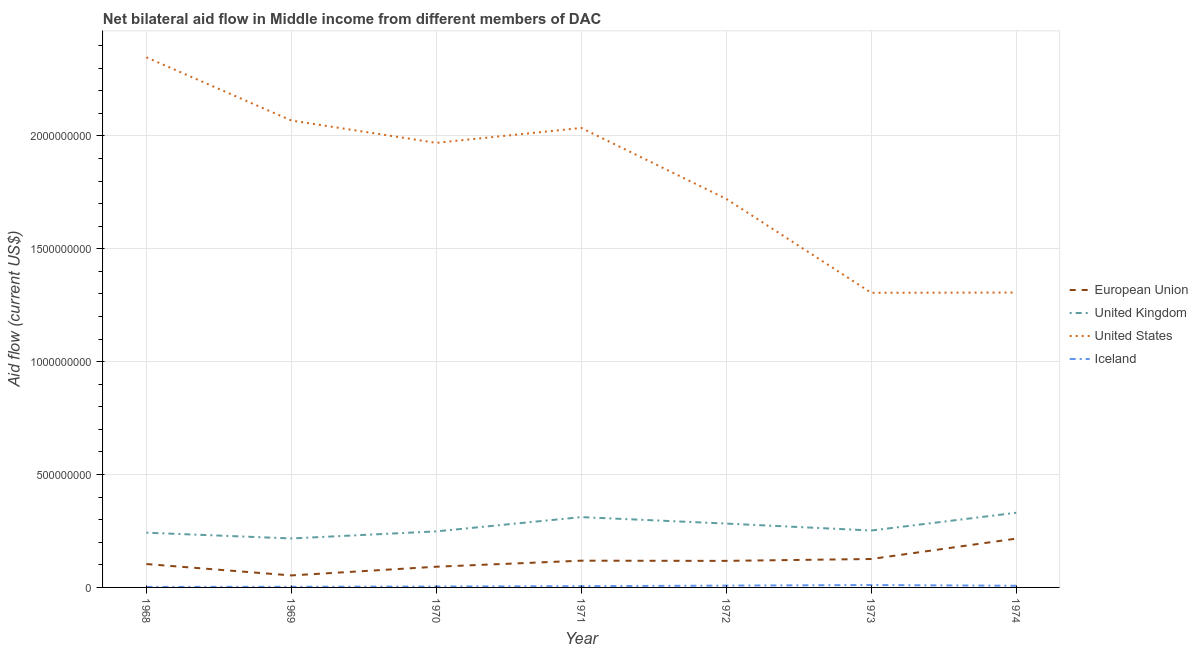Is the number of lines equal to the number of legend labels?
Ensure brevity in your answer.  Yes. What is the amount of aid given by uk in 1974?
Offer a terse response. 3.31e+08. Across all years, what is the maximum amount of aid given by uk?
Offer a very short reply. 3.31e+08. Across all years, what is the minimum amount of aid given by us?
Ensure brevity in your answer.  1.30e+09. In which year was the amount of aid given by uk maximum?
Your response must be concise. 1974. In which year was the amount of aid given by us minimum?
Offer a terse response. 1973. What is the total amount of aid given by uk in the graph?
Your answer should be compact. 1.88e+09. What is the difference between the amount of aid given by us in 1969 and that in 1973?
Your response must be concise. 7.63e+08. What is the difference between the amount of aid given by uk in 1972 and the amount of aid given by us in 1968?
Your response must be concise. -2.07e+09. What is the average amount of aid given by us per year?
Provide a succinct answer. 1.82e+09. In the year 1972, what is the difference between the amount of aid given by eu and amount of aid given by uk?
Your answer should be compact. -1.65e+08. What is the ratio of the amount of aid given by uk in 1970 to that in 1971?
Your response must be concise. 0.8. What is the difference between the highest and the second highest amount of aid given by iceland?
Keep it short and to the point. 2.57e+06. What is the difference between the highest and the lowest amount of aid given by us?
Give a very brief answer. 1.04e+09. Is it the case that in every year, the sum of the amount of aid given by iceland and amount of aid given by uk is greater than the sum of amount of aid given by eu and amount of aid given by us?
Provide a short and direct response. No. How many years are there in the graph?
Give a very brief answer. 7. Does the graph contain any zero values?
Make the answer very short. No. How many legend labels are there?
Your answer should be very brief. 4. How are the legend labels stacked?
Keep it short and to the point. Vertical. What is the title of the graph?
Provide a succinct answer. Net bilateral aid flow in Middle income from different members of DAC. Does "Quality Certification" appear as one of the legend labels in the graph?
Offer a terse response. No. What is the label or title of the X-axis?
Provide a succinct answer. Year. What is the Aid flow (current US$) of European Union in 1968?
Make the answer very short. 1.04e+08. What is the Aid flow (current US$) of United Kingdom in 1968?
Give a very brief answer. 2.42e+08. What is the Aid flow (current US$) of United States in 1968?
Your answer should be compact. 2.35e+09. What is the Aid flow (current US$) in Iceland in 1968?
Provide a short and direct response. 2.25e+06. What is the Aid flow (current US$) in European Union in 1969?
Offer a terse response. 5.32e+07. What is the Aid flow (current US$) in United Kingdom in 1969?
Keep it short and to the point. 2.17e+08. What is the Aid flow (current US$) of United States in 1969?
Provide a succinct answer. 2.07e+09. What is the Aid flow (current US$) of Iceland in 1969?
Offer a very short reply. 2.86e+06. What is the Aid flow (current US$) in European Union in 1970?
Give a very brief answer. 9.17e+07. What is the Aid flow (current US$) in United Kingdom in 1970?
Keep it short and to the point. 2.48e+08. What is the Aid flow (current US$) of United States in 1970?
Offer a very short reply. 1.97e+09. What is the Aid flow (current US$) of Iceland in 1970?
Offer a very short reply. 4.10e+06. What is the Aid flow (current US$) of European Union in 1971?
Your answer should be compact. 1.18e+08. What is the Aid flow (current US$) of United Kingdom in 1971?
Ensure brevity in your answer.  3.11e+08. What is the Aid flow (current US$) of United States in 1971?
Keep it short and to the point. 2.04e+09. What is the Aid flow (current US$) of Iceland in 1971?
Offer a terse response. 5.55e+06. What is the Aid flow (current US$) in European Union in 1972?
Give a very brief answer. 1.18e+08. What is the Aid flow (current US$) of United Kingdom in 1972?
Your answer should be very brief. 2.83e+08. What is the Aid flow (current US$) of United States in 1972?
Offer a very short reply. 1.72e+09. What is the Aid flow (current US$) of Iceland in 1972?
Your response must be concise. 8.06e+06. What is the Aid flow (current US$) in European Union in 1973?
Make the answer very short. 1.26e+08. What is the Aid flow (current US$) in United Kingdom in 1973?
Your response must be concise. 2.52e+08. What is the Aid flow (current US$) in United States in 1973?
Provide a succinct answer. 1.30e+09. What is the Aid flow (current US$) in Iceland in 1973?
Keep it short and to the point. 1.06e+07. What is the Aid flow (current US$) in European Union in 1974?
Give a very brief answer. 2.16e+08. What is the Aid flow (current US$) in United Kingdom in 1974?
Your response must be concise. 3.31e+08. What is the Aid flow (current US$) in United States in 1974?
Give a very brief answer. 1.31e+09. What is the Aid flow (current US$) of Iceland in 1974?
Provide a short and direct response. 7.38e+06. Across all years, what is the maximum Aid flow (current US$) of European Union?
Provide a succinct answer. 2.16e+08. Across all years, what is the maximum Aid flow (current US$) of United Kingdom?
Your answer should be compact. 3.31e+08. Across all years, what is the maximum Aid flow (current US$) of United States?
Offer a terse response. 2.35e+09. Across all years, what is the maximum Aid flow (current US$) of Iceland?
Offer a terse response. 1.06e+07. Across all years, what is the minimum Aid flow (current US$) in European Union?
Offer a terse response. 5.32e+07. Across all years, what is the minimum Aid flow (current US$) in United Kingdom?
Make the answer very short. 2.17e+08. Across all years, what is the minimum Aid flow (current US$) of United States?
Make the answer very short. 1.30e+09. Across all years, what is the minimum Aid flow (current US$) of Iceland?
Keep it short and to the point. 2.25e+06. What is the total Aid flow (current US$) in European Union in the graph?
Provide a short and direct response. 8.27e+08. What is the total Aid flow (current US$) of United Kingdom in the graph?
Offer a terse response. 1.88e+09. What is the total Aid flow (current US$) of United States in the graph?
Make the answer very short. 1.28e+1. What is the total Aid flow (current US$) in Iceland in the graph?
Your answer should be very brief. 4.08e+07. What is the difference between the Aid flow (current US$) in European Union in 1968 and that in 1969?
Your answer should be compact. 5.04e+07. What is the difference between the Aid flow (current US$) in United Kingdom in 1968 and that in 1969?
Provide a succinct answer. 2.55e+07. What is the difference between the Aid flow (current US$) in United States in 1968 and that in 1969?
Your answer should be very brief. 2.80e+08. What is the difference between the Aid flow (current US$) of Iceland in 1968 and that in 1969?
Provide a succinct answer. -6.10e+05. What is the difference between the Aid flow (current US$) in European Union in 1968 and that in 1970?
Ensure brevity in your answer.  1.19e+07. What is the difference between the Aid flow (current US$) in United Kingdom in 1968 and that in 1970?
Your answer should be very brief. -5.81e+06. What is the difference between the Aid flow (current US$) in United States in 1968 and that in 1970?
Ensure brevity in your answer.  3.79e+08. What is the difference between the Aid flow (current US$) in Iceland in 1968 and that in 1970?
Offer a very short reply. -1.85e+06. What is the difference between the Aid flow (current US$) in European Union in 1968 and that in 1971?
Your response must be concise. -1.48e+07. What is the difference between the Aid flow (current US$) in United Kingdom in 1968 and that in 1971?
Ensure brevity in your answer.  -6.90e+07. What is the difference between the Aid flow (current US$) of United States in 1968 and that in 1971?
Offer a terse response. 3.13e+08. What is the difference between the Aid flow (current US$) of Iceland in 1968 and that in 1971?
Your answer should be very brief. -3.30e+06. What is the difference between the Aid flow (current US$) in European Union in 1968 and that in 1972?
Provide a succinct answer. -1.40e+07. What is the difference between the Aid flow (current US$) in United Kingdom in 1968 and that in 1972?
Offer a very short reply. -4.04e+07. What is the difference between the Aid flow (current US$) of United States in 1968 and that in 1972?
Give a very brief answer. 6.27e+08. What is the difference between the Aid flow (current US$) in Iceland in 1968 and that in 1972?
Make the answer very short. -5.81e+06. What is the difference between the Aid flow (current US$) of European Union in 1968 and that in 1973?
Offer a terse response. -2.23e+07. What is the difference between the Aid flow (current US$) of United Kingdom in 1968 and that in 1973?
Make the answer very short. -9.66e+06. What is the difference between the Aid flow (current US$) in United States in 1968 and that in 1973?
Provide a short and direct response. 1.04e+09. What is the difference between the Aid flow (current US$) in Iceland in 1968 and that in 1973?
Make the answer very short. -8.38e+06. What is the difference between the Aid flow (current US$) of European Union in 1968 and that in 1974?
Your response must be concise. -1.13e+08. What is the difference between the Aid flow (current US$) of United Kingdom in 1968 and that in 1974?
Keep it short and to the point. -8.82e+07. What is the difference between the Aid flow (current US$) in United States in 1968 and that in 1974?
Keep it short and to the point. 1.04e+09. What is the difference between the Aid flow (current US$) of Iceland in 1968 and that in 1974?
Offer a very short reply. -5.13e+06. What is the difference between the Aid flow (current US$) of European Union in 1969 and that in 1970?
Offer a terse response. -3.86e+07. What is the difference between the Aid flow (current US$) of United Kingdom in 1969 and that in 1970?
Your answer should be very brief. -3.13e+07. What is the difference between the Aid flow (current US$) of United States in 1969 and that in 1970?
Provide a succinct answer. 9.90e+07. What is the difference between the Aid flow (current US$) of Iceland in 1969 and that in 1970?
Ensure brevity in your answer.  -1.24e+06. What is the difference between the Aid flow (current US$) in European Union in 1969 and that in 1971?
Give a very brief answer. -6.53e+07. What is the difference between the Aid flow (current US$) of United Kingdom in 1969 and that in 1971?
Provide a succinct answer. -9.45e+07. What is the difference between the Aid flow (current US$) of United States in 1969 and that in 1971?
Ensure brevity in your answer.  3.30e+07. What is the difference between the Aid flow (current US$) in Iceland in 1969 and that in 1971?
Your answer should be very brief. -2.69e+06. What is the difference between the Aid flow (current US$) in European Union in 1969 and that in 1972?
Your answer should be compact. -6.44e+07. What is the difference between the Aid flow (current US$) of United Kingdom in 1969 and that in 1972?
Ensure brevity in your answer.  -6.59e+07. What is the difference between the Aid flow (current US$) in United States in 1969 and that in 1972?
Provide a succinct answer. 3.47e+08. What is the difference between the Aid flow (current US$) in Iceland in 1969 and that in 1972?
Your answer should be compact. -5.20e+06. What is the difference between the Aid flow (current US$) of European Union in 1969 and that in 1973?
Provide a short and direct response. -7.28e+07. What is the difference between the Aid flow (current US$) in United Kingdom in 1969 and that in 1973?
Keep it short and to the point. -3.52e+07. What is the difference between the Aid flow (current US$) in United States in 1969 and that in 1973?
Keep it short and to the point. 7.63e+08. What is the difference between the Aid flow (current US$) in Iceland in 1969 and that in 1973?
Provide a succinct answer. -7.77e+06. What is the difference between the Aid flow (current US$) in European Union in 1969 and that in 1974?
Keep it short and to the point. -1.63e+08. What is the difference between the Aid flow (current US$) in United Kingdom in 1969 and that in 1974?
Ensure brevity in your answer.  -1.14e+08. What is the difference between the Aid flow (current US$) in United States in 1969 and that in 1974?
Provide a succinct answer. 7.62e+08. What is the difference between the Aid flow (current US$) in Iceland in 1969 and that in 1974?
Keep it short and to the point. -4.52e+06. What is the difference between the Aid flow (current US$) in European Union in 1970 and that in 1971?
Your answer should be compact. -2.67e+07. What is the difference between the Aid flow (current US$) of United Kingdom in 1970 and that in 1971?
Offer a terse response. -6.32e+07. What is the difference between the Aid flow (current US$) in United States in 1970 and that in 1971?
Ensure brevity in your answer.  -6.60e+07. What is the difference between the Aid flow (current US$) in Iceland in 1970 and that in 1971?
Make the answer very short. -1.45e+06. What is the difference between the Aid flow (current US$) of European Union in 1970 and that in 1972?
Make the answer very short. -2.59e+07. What is the difference between the Aid flow (current US$) of United Kingdom in 1970 and that in 1972?
Provide a short and direct response. -3.46e+07. What is the difference between the Aid flow (current US$) of United States in 1970 and that in 1972?
Your answer should be compact. 2.48e+08. What is the difference between the Aid flow (current US$) in Iceland in 1970 and that in 1972?
Your response must be concise. -3.96e+06. What is the difference between the Aid flow (current US$) of European Union in 1970 and that in 1973?
Keep it short and to the point. -3.42e+07. What is the difference between the Aid flow (current US$) of United Kingdom in 1970 and that in 1973?
Give a very brief answer. -3.85e+06. What is the difference between the Aid flow (current US$) in United States in 1970 and that in 1973?
Ensure brevity in your answer.  6.64e+08. What is the difference between the Aid flow (current US$) in Iceland in 1970 and that in 1973?
Make the answer very short. -6.53e+06. What is the difference between the Aid flow (current US$) in European Union in 1970 and that in 1974?
Offer a very short reply. -1.24e+08. What is the difference between the Aid flow (current US$) of United Kingdom in 1970 and that in 1974?
Give a very brief answer. -8.24e+07. What is the difference between the Aid flow (current US$) of United States in 1970 and that in 1974?
Keep it short and to the point. 6.63e+08. What is the difference between the Aid flow (current US$) in Iceland in 1970 and that in 1974?
Give a very brief answer. -3.28e+06. What is the difference between the Aid flow (current US$) of European Union in 1971 and that in 1972?
Offer a terse response. 8.10e+05. What is the difference between the Aid flow (current US$) of United Kingdom in 1971 and that in 1972?
Keep it short and to the point. 2.86e+07. What is the difference between the Aid flow (current US$) of United States in 1971 and that in 1972?
Offer a terse response. 3.14e+08. What is the difference between the Aid flow (current US$) of Iceland in 1971 and that in 1972?
Offer a very short reply. -2.51e+06. What is the difference between the Aid flow (current US$) of European Union in 1971 and that in 1973?
Make the answer very short. -7.50e+06. What is the difference between the Aid flow (current US$) of United Kingdom in 1971 and that in 1973?
Give a very brief answer. 5.93e+07. What is the difference between the Aid flow (current US$) of United States in 1971 and that in 1973?
Offer a terse response. 7.30e+08. What is the difference between the Aid flow (current US$) in Iceland in 1971 and that in 1973?
Your response must be concise. -5.08e+06. What is the difference between the Aid flow (current US$) in European Union in 1971 and that in 1974?
Your response must be concise. -9.78e+07. What is the difference between the Aid flow (current US$) in United Kingdom in 1971 and that in 1974?
Provide a short and direct response. -1.92e+07. What is the difference between the Aid flow (current US$) of United States in 1971 and that in 1974?
Make the answer very short. 7.29e+08. What is the difference between the Aid flow (current US$) of Iceland in 1971 and that in 1974?
Give a very brief answer. -1.83e+06. What is the difference between the Aid flow (current US$) in European Union in 1972 and that in 1973?
Your answer should be very brief. -8.31e+06. What is the difference between the Aid flow (current US$) of United Kingdom in 1972 and that in 1973?
Offer a terse response. 3.08e+07. What is the difference between the Aid flow (current US$) of United States in 1972 and that in 1973?
Give a very brief answer. 4.16e+08. What is the difference between the Aid flow (current US$) of Iceland in 1972 and that in 1973?
Give a very brief answer. -2.57e+06. What is the difference between the Aid flow (current US$) in European Union in 1972 and that in 1974?
Offer a terse response. -9.86e+07. What is the difference between the Aid flow (current US$) in United Kingdom in 1972 and that in 1974?
Provide a succinct answer. -4.78e+07. What is the difference between the Aid flow (current US$) in United States in 1972 and that in 1974?
Offer a very short reply. 4.15e+08. What is the difference between the Aid flow (current US$) of Iceland in 1972 and that in 1974?
Provide a succinct answer. 6.80e+05. What is the difference between the Aid flow (current US$) in European Union in 1973 and that in 1974?
Provide a succinct answer. -9.03e+07. What is the difference between the Aid flow (current US$) in United Kingdom in 1973 and that in 1974?
Your answer should be very brief. -7.86e+07. What is the difference between the Aid flow (current US$) in United States in 1973 and that in 1974?
Offer a very short reply. -1.00e+06. What is the difference between the Aid flow (current US$) in Iceland in 1973 and that in 1974?
Your answer should be compact. 3.25e+06. What is the difference between the Aid flow (current US$) in European Union in 1968 and the Aid flow (current US$) in United Kingdom in 1969?
Provide a succinct answer. -1.13e+08. What is the difference between the Aid flow (current US$) in European Union in 1968 and the Aid flow (current US$) in United States in 1969?
Offer a very short reply. -1.96e+09. What is the difference between the Aid flow (current US$) of European Union in 1968 and the Aid flow (current US$) of Iceland in 1969?
Offer a very short reply. 1.01e+08. What is the difference between the Aid flow (current US$) in United Kingdom in 1968 and the Aid flow (current US$) in United States in 1969?
Your answer should be very brief. -1.83e+09. What is the difference between the Aid flow (current US$) of United Kingdom in 1968 and the Aid flow (current US$) of Iceland in 1969?
Ensure brevity in your answer.  2.40e+08. What is the difference between the Aid flow (current US$) in United States in 1968 and the Aid flow (current US$) in Iceland in 1969?
Your answer should be very brief. 2.35e+09. What is the difference between the Aid flow (current US$) of European Union in 1968 and the Aid flow (current US$) of United Kingdom in 1970?
Offer a terse response. -1.45e+08. What is the difference between the Aid flow (current US$) in European Union in 1968 and the Aid flow (current US$) in United States in 1970?
Keep it short and to the point. -1.87e+09. What is the difference between the Aid flow (current US$) of European Union in 1968 and the Aid flow (current US$) of Iceland in 1970?
Ensure brevity in your answer.  9.95e+07. What is the difference between the Aid flow (current US$) of United Kingdom in 1968 and the Aid flow (current US$) of United States in 1970?
Provide a short and direct response. -1.73e+09. What is the difference between the Aid flow (current US$) in United Kingdom in 1968 and the Aid flow (current US$) in Iceland in 1970?
Offer a very short reply. 2.38e+08. What is the difference between the Aid flow (current US$) in United States in 1968 and the Aid flow (current US$) in Iceland in 1970?
Provide a succinct answer. 2.34e+09. What is the difference between the Aid flow (current US$) of European Union in 1968 and the Aid flow (current US$) of United Kingdom in 1971?
Give a very brief answer. -2.08e+08. What is the difference between the Aid flow (current US$) of European Union in 1968 and the Aid flow (current US$) of United States in 1971?
Make the answer very short. -1.93e+09. What is the difference between the Aid flow (current US$) of European Union in 1968 and the Aid flow (current US$) of Iceland in 1971?
Make the answer very short. 9.80e+07. What is the difference between the Aid flow (current US$) in United Kingdom in 1968 and the Aid flow (current US$) in United States in 1971?
Provide a succinct answer. -1.79e+09. What is the difference between the Aid flow (current US$) of United Kingdom in 1968 and the Aid flow (current US$) of Iceland in 1971?
Offer a terse response. 2.37e+08. What is the difference between the Aid flow (current US$) of United States in 1968 and the Aid flow (current US$) of Iceland in 1971?
Offer a very short reply. 2.34e+09. What is the difference between the Aid flow (current US$) in European Union in 1968 and the Aid flow (current US$) in United Kingdom in 1972?
Your answer should be compact. -1.79e+08. What is the difference between the Aid flow (current US$) in European Union in 1968 and the Aid flow (current US$) in United States in 1972?
Give a very brief answer. -1.62e+09. What is the difference between the Aid flow (current US$) of European Union in 1968 and the Aid flow (current US$) of Iceland in 1972?
Offer a very short reply. 9.55e+07. What is the difference between the Aid flow (current US$) in United Kingdom in 1968 and the Aid flow (current US$) in United States in 1972?
Provide a succinct answer. -1.48e+09. What is the difference between the Aid flow (current US$) of United Kingdom in 1968 and the Aid flow (current US$) of Iceland in 1972?
Ensure brevity in your answer.  2.34e+08. What is the difference between the Aid flow (current US$) in United States in 1968 and the Aid flow (current US$) in Iceland in 1972?
Your response must be concise. 2.34e+09. What is the difference between the Aid flow (current US$) of European Union in 1968 and the Aid flow (current US$) of United Kingdom in 1973?
Your answer should be very brief. -1.48e+08. What is the difference between the Aid flow (current US$) of European Union in 1968 and the Aid flow (current US$) of United States in 1973?
Give a very brief answer. -1.20e+09. What is the difference between the Aid flow (current US$) of European Union in 1968 and the Aid flow (current US$) of Iceland in 1973?
Offer a very short reply. 9.30e+07. What is the difference between the Aid flow (current US$) in United Kingdom in 1968 and the Aid flow (current US$) in United States in 1973?
Your answer should be compact. -1.06e+09. What is the difference between the Aid flow (current US$) of United Kingdom in 1968 and the Aid flow (current US$) of Iceland in 1973?
Your response must be concise. 2.32e+08. What is the difference between the Aid flow (current US$) in United States in 1968 and the Aid flow (current US$) in Iceland in 1973?
Provide a short and direct response. 2.34e+09. What is the difference between the Aid flow (current US$) in European Union in 1968 and the Aid flow (current US$) in United Kingdom in 1974?
Make the answer very short. -2.27e+08. What is the difference between the Aid flow (current US$) in European Union in 1968 and the Aid flow (current US$) in United States in 1974?
Your answer should be very brief. -1.20e+09. What is the difference between the Aid flow (current US$) in European Union in 1968 and the Aid flow (current US$) in Iceland in 1974?
Offer a terse response. 9.62e+07. What is the difference between the Aid flow (current US$) in United Kingdom in 1968 and the Aid flow (current US$) in United States in 1974?
Ensure brevity in your answer.  -1.06e+09. What is the difference between the Aid flow (current US$) in United Kingdom in 1968 and the Aid flow (current US$) in Iceland in 1974?
Offer a very short reply. 2.35e+08. What is the difference between the Aid flow (current US$) of United States in 1968 and the Aid flow (current US$) of Iceland in 1974?
Provide a succinct answer. 2.34e+09. What is the difference between the Aid flow (current US$) of European Union in 1969 and the Aid flow (current US$) of United Kingdom in 1970?
Your response must be concise. -1.95e+08. What is the difference between the Aid flow (current US$) in European Union in 1969 and the Aid flow (current US$) in United States in 1970?
Offer a terse response. -1.92e+09. What is the difference between the Aid flow (current US$) in European Union in 1969 and the Aid flow (current US$) in Iceland in 1970?
Provide a succinct answer. 4.90e+07. What is the difference between the Aid flow (current US$) in United Kingdom in 1969 and the Aid flow (current US$) in United States in 1970?
Provide a succinct answer. -1.75e+09. What is the difference between the Aid flow (current US$) of United Kingdom in 1969 and the Aid flow (current US$) of Iceland in 1970?
Your answer should be very brief. 2.13e+08. What is the difference between the Aid flow (current US$) of United States in 1969 and the Aid flow (current US$) of Iceland in 1970?
Provide a succinct answer. 2.06e+09. What is the difference between the Aid flow (current US$) of European Union in 1969 and the Aid flow (current US$) of United Kingdom in 1971?
Make the answer very short. -2.58e+08. What is the difference between the Aid flow (current US$) in European Union in 1969 and the Aid flow (current US$) in United States in 1971?
Your answer should be very brief. -1.98e+09. What is the difference between the Aid flow (current US$) of European Union in 1969 and the Aid flow (current US$) of Iceland in 1971?
Give a very brief answer. 4.76e+07. What is the difference between the Aid flow (current US$) in United Kingdom in 1969 and the Aid flow (current US$) in United States in 1971?
Provide a succinct answer. -1.82e+09. What is the difference between the Aid flow (current US$) of United Kingdom in 1969 and the Aid flow (current US$) of Iceland in 1971?
Make the answer very short. 2.11e+08. What is the difference between the Aid flow (current US$) in United States in 1969 and the Aid flow (current US$) in Iceland in 1971?
Ensure brevity in your answer.  2.06e+09. What is the difference between the Aid flow (current US$) of European Union in 1969 and the Aid flow (current US$) of United Kingdom in 1972?
Keep it short and to the point. -2.30e+08. What is the difference between the Aid flow (current US$) of European Union in 1969 and the Aid flow (current US$) of United States in 1972?
Ensure brevity in your answer.  -1.67e+09. What is the difference between the Aid flow (current US$) in European Union in 1969 and the Aid flow (current US$) in Iceland in 1972?
Keep it short and to the point. 4.51e+07. What is the difference between the Aid flow (current US$) in United Kingdom in 1969 and the Aid flow (current US$) in United States in 1972?
Your response must be concise. -1.50e+09. What is the difference between the Aid flow (current US$) in United Kingdom in 1969 and the Aid flow (current US$) in Iceland in 1972?
Provide a short and direct response. 2.09e+08. What is the difference between the Aid flow (current US$) in United States in 1969 and the Aid flow (current US$) in Iceland in 1972?
Offer a very short reply. 2.06e+09. What is the difference between the Aid flow (current US$) of European Union in 1969 and the Aid flow (current US$) of United Kingdom in 1973?
Ensure brevity in your answer.  -1.99e+08. What is the difference between the Aid flow (current US$) in European Union in 1969 and the Aid flow (current US$) in United States in 1973?
Make the answer very short. -1.25e+09. What is the difference between the Aid flow (current US$) in European Union in 1969 and the Aid flow (current US$) in Iceland in 1973?
Provide a succinct answer. 4.25e+07. What is the difference between the Aid flow (current US$) in United Kingdom in 1969 and the Aid flow (current US$) in United States in 1973?
Offer a terse response. -1.09e+09. What is the difference between the Aid flow (current US$) of United Kingdom in 1969 and the Aid flow (current US$) of Iceland in 1973?
Give a very brief answer. 2.06e+08. What is the difference between the Aid flow (current US$) of United States in 1969 and the Aid flow (current US$) of Iceland in 1973?
Offer a terse response. 2.06e+09. What is the difference between the Aid flow (current US$) in European Union in 1969 and the Aid flow (current US$) in United Kingdom in 1974?
Your answer should be very brief. -2.77e+08. What is the difference between the Aid flow (current US$) in European Union in 1969 and the Aid flow (current US$) in United States in 1974?
Offer a terse response. -1.25e+09. What is the difference between the Aid flow (current US$) of European Union in 1969 and the Aid flow (current US$) of Iceland in 1974?
Your answer should be compact. 4.58e+07. What is the difference between the Aid flow (current US$) in United Kingdom in 1969 and the Aid flow (current US$) in United States in 1974?
Provide a succinct answer. -1.09e+09. What is the difference between the Aid flow (current US$) of United Kingdom in 1969 and the Aid flow (current US$) of Iceland in 1974?
Provide a succinct answer. 2.10e+08. What is the difference between the Aid flow (current US$) in United States in 1969 and the Aid flow (current US$) in Iceland in 1974?
Ensure brevity in your answer.  2.06e+09. What is the difference between the Aid flow (current US$) of European Union in 1970 and the Aid flow (current US$) of United Kingdom in 1971?
Your answer should be very brief. -2.20e+08. What is the difference between the Aid flow (current US$) in European Union in 1970 and the Aid flow (current US$) in United States in 1971?
Provide a succinct answer. -1.94e+09. What is the difference between the Aid flow (current US$) of European Union in 1970 and the Aid flow (current US$) of Iceland in 1971?
Offer a terse response. 8.62e+07. What is the difference between the Aid flow (current US$) in United Kingdom in 1970 and the Aid flow (current US$) in United States in 1971?
Offer a terse response. -1.79e+09. What is the difference between the Aid flow (current US$) in United Kingdom in 1970 and the Aid flow (current US$) in Iceland in 1971?
Keep it short and to the point. 2.43e+08. What is the difference between the Aid flow (current US$) in United States in 1970 and the Aid flow (current US$) in Iceland in 1971?
Provide a succinct answer. 1.96e+09. What is the difference between the Aid flow (current US$) in European Union in 1970 and the Aid flow (current US$) in United Kingdom in 1972?
Offer a very short reply. -1.91e+08. What is the difference between the Aid flow (current US$) of European Union in 1970 and the Aid flow (current US$) of United States in 1972?
Your response must be concise. -1.63e+09. What is the difference between the Aid flow (current US$) of European Union in 1970 and the Aid flow (current US$) of Iceland in 1972?
Provide a succinct answer. 8.37e+07. What is the difference between the Aid flow (current US$) in United Kingdom in 1970 and the Aid flow (current US$) in United States in 1972?
Provide a succinct answer. -1.47e+09. What is the difference between the Aid flow (current US$) in United Kingdom in 1970 and the Aid flow (current US$) in Iceland in 1972?
Your answer should be compact. 2.40e+08. What is the difference between the Aid flow (current US$) of United States in 1970 and the Aid flow (current US$) of Iceland in 1972?
Provide a succinct answer. 1.96e+09. What is the difference between the Aid flow (current US$) of European Union in 1970 and the Aid flow (current US$) of United Kingdom in 1973?
Your response must be concise. -1.60e+08. What is the difference between the Aid flow (current US$) of European Union in 1970 and the Aid flow (current US$) of United States in 1973?
Offer a very short reply. -1.21e+09. What is the difference between the Aid flow (current US$) in European Union in 1970 and the Aid flow (current US$) in Iceland in 1973?
Make the answer very short. 8.11e+07. What is the difference between the Aid flow (current US$) in United Kingdom in 1970 and the Aid flow (current US$) in United States in 1973?
Offer a terse response. -1.06e+09. What is the difference between the Aid flow (current US$) of United Kingdom in 1970 and the Aid flow (current US$) of Iceland in 1973?
Your answer should be compact. 2.38e+08. What is the difference between the Aid flow (current US$) in United States in 1970 and the Aid flow (current US$) in Iceland in 1973?
Provide a succinct answer. 1.96e+09. What is the difference between the Aid flow (current US$) of European Union in 1970 and the Aid flow (current US$) of United Kingdom in 1974?
Give a very brief answer. -2.39e+08. What is the difference between the Aid flow (current US$) of European Union in 1970 and the Aid flow (current US$) of United States in 1974?
Your answer should be compact. -1.21e+09. What is the difference between the Aid flow (current US$) in European Union in 1970 and the Aid flow (current US$) in Iceland in 1974?
Keep it short and to the point. 8.43e+07. What is the difference between the Aid flow (current US$) in United Kingdom in 1970 and the Aid flow (current US$) in United States in 1974?
Your answer should be compact. -1.06e+09. What is the difference between the Aid flow (current US$) of United Kingdom in 1970 and the Aid flow (current US$) of Iceland in 1974?
Your answer should be very brief. 2.41e+08. What is the difference between the Aid flow (current US$) in United States in 1970 and the Aid flow (current US$) in Iceland in 1974?
Your answer should be very brief. 1.96e+09. What is the difference between the Aid flow (current US$) in European Union in 1971 and the Aid flow (current US$) in United Kingdom in 1972?
Your answer should be very brief. -1.64e+08. What is the difference between the Aid flow (current US$) of European Union in 1971 and the Aid flow (current US$) of United States in 1972?
Give a very brief answer. -1.60e+09. What is the difference between the Aid flow (current US$) in European Union in 1971 and the Aid flow (current US$) in Iceland in 1972?
Offer a terse response. 1.10e+08. What is the difference between the Aid flow (current US$) of United Kingdom in 1971 and the Aid flow (current US$) of United States in 1972?
Your answer should be very brief. -1.41e+09. What is the difference between the Aid flow (current US$) in United Kingdom in 1971 and the Aid flow (current US$) in Iceland in 1972?
Give a very brief answer. 3.03e+08. What is the difference between the Aid flow (current US$) of United States in 1971 and the Aid flow (current US$) of Iceland in 1972?
Your answer should be compact. 2.03e+09. What is the difference between the Aid flow (current US$) of European Union in 1971 and the Aid flow (current US$) of United Kingdom in 1973?
Give a very brief answer. -1.34e+08. What is the difference between the Aid flow (current US$) in European Union in 1971 and the Aid flow (current US$) in United States in 1973?
Your response must be concise. -1.19e+09. What is the difference between the Aid flow (current US$) of European Union in 1971 and the Aid flow (current US$) of Iceland in 1973?
Keep it short and to the point. 1.08e+08. What is the difference between the Aid flow (current US$) in United Kingdom in 1971 and the Aid flow (current US$) in United States in 1973?
Ensure brevity in your answer.  -9.94e+08. What is the difference between the Aid flow (current US$) of United Kingdom in 1971 and the Aid flow (current US$) of Iceland in 1973?
Give a very brief answer. 3.01e+08. What is the difference between the Aid flow (current US$) in United States in 1971 and the Aid flow (current US$) in Iceland in 1973?
Give a very brief answer. 2.02e+09. What is the difference between the Aid flow (current US$) in European Union in 1971 and the Aid flow (current US$) in United Kingdom in 1974?
Provide a succinct answer. -2.12e+08. What is the difference between the Aid flow (current US$) of European Union in 1971 and the Aid flow (current US$) of United States in 1974?
Offer a terse response. -1.19e+09. What is the difference between the Aid flow (current US$) in European Union in 1971 and the Aid flow (current US$) in Iceland in 1974?
Keep it short and to the point. 1.11e+08. What is the difference between the Aid flow (current US$) of United Kingdom in 1971 and the Aid flow (current US$) of United States in 1974?
Offer a terse response. -9.95e+08. What is the difference between the Aid flow (current US$) of United Kingdom in 1971 and the Aid flow (current US$) of Iceland in 1974?
Make the answer very short. 3.04e+08. What is the difference between the Aid flow (current US$) of United States in 1971 and the Aid flow (current US$) of Iceland in 1974?
Your answer should be very brief. 2.03e+09. What is the difference between the Aid flow (current US$) in European Union in 1972 and the Aid flow (current US$) in United Kingdom in 1973?
Provide a short and direct response. -1.34e+08. What is the difference between the Aid flow (current US$) in European Union in 1972 and the Aid flow (current US$) in United States in 1973?
Make the answer very short. -1.19e+09. What is the difference between the Aid flow (current US$) of European Union in 1972 and the Aid flow (current US$) of Iceland in 1973?
Offer a terse response. 1.07e+08. What is the difference between the Aid flow (current US$) in United Kingdom in 1972 and the Aid flow (current US$) in United States in 1973?
Provide a short and direct response. -1.02e+09. What is the difference between the Aid flow (current US$) in United Kingdom in 1972 and the Aid flow (current US$) in Iceland in 1973?
Offer a terse response. 2.72e+08. What is the difference between the Aid flow (current US$) in United States in 1972 and the Aid flow (current US$) in Iceland in 1973?
Provide a short and direct response. 1.71e+09. What is the difference between the Aid flow (current US$) in European Union in 1972 and the Aid flow (current US$) in United Kingdom in 1974?
Ensure brevity in your answer.  -2.13e+08. What is the difference between the Aid flow (current US$) of European Union in 1972 and the Aid flow (current US$) of United States in 1974?
Make the answer very short. -1.19e+09. What is the difference between the Aid flow (current US$) in European Union in 1972 and the Aid flow (current US$) in Iceland in 1974?
Your response must be concise. 1.10e+08. What is the difference between the Aid flow (current US$) of United Kingdom in 1972 and the Aid flow (current US$) of United States in 1974?
Keep it short and to the point. -1.02e+09. What is the difference between the Aid flow (current US$) of United Kingdom in 1972 and the Aid flow (current US$) of Iceland in 1974?
Keep it short and to the point. 2.75e+08. What is the difference between the Aid flow (current US$) in United States in 1972 and the Aid flow (current US$) in Iceland in 1974?
Your response must be concise. 1.71e+09. What is the difference between the Aid flow (current US$) in European Union in 1973 and the Aid flow (current US$) in United Kingdom in 1974?
Your answer should be very brief. -2.05e+08. What is the difference between the Aid flow (current US$) in European Union in 1973 and the Aid flow (current US$) in United States in 1974?
Offer a very short reply. -1.18e+09. What is the difference between the Aid flow (current US$) in European Union in 1973 and the Aid flow (current US$) in Iceland in 1974?
Offer a very short reply. 1.19e+08. What is the difference between the Aid flow (current US$) of United Kingdom in 1973 and the Aid flow (current US$) of United States in 1974?
Provide a succinct answer. -1.05e+09. What is the difference between the Aid flow (current US$) in United Kingdom in 1973 and the Aid flow (current US$) in Iceland in 1974?
Provide a short and direct response. 2.45e+08. What is the difference between the Aid flow (current US$) of United States in 1973 and the Aid flow (current US$) of Iceland in 1974?
Ensure brevity in your answer.  1.30e+09. What is the average Aid flow (current US$) of European Union per year?
Your response must be concise. 1.18e+08. What is the average Aid flow (current US$) of United Kingdom per year?
Offer a terse response. 2.69e+08. What is the average Aid flow (current US$) in United States per year?
Your answer should be compact. 1.82e+09. What is the average Aid flow (current US$) of Iceland per year?
Keep it short and to the point. 5.83e+06. In the year 1968, what is the difference between the Aid flow (current US$) of European Union and Aid flow (current US$) of United Kingdom?
Ensure brevity in your answer.  -1.39e+08. In the year 1968, what is the difference between the Aid flow (current US$) of European Union and Aid flow (current US$) of United States?
Give a very brief answer. -2.24e+09. In the year 1968, what is the difference between the Aid flow (current US$) of European Union and Aid flow (current US$) of Iceland?
Keep it short and to the point. 1.01e+08. In the year 1968, what is the difference between the Aid flow (current US$) of United Kingdom and Aid flow (current US$) of United States?
Offer a very short reply. -2.11e+09. In the year 1968, what is the difference between the Aid flow (current US$) of United Kingdom and Aid flow (current US$) of Iceland?
Offer a very short reply. 2.40e+08. In the year 1968, what is the difference between the Aid flow (current US$) of United States and Aid flow (current US$) of Iceland?
Make the answer very short. 2.35e+09. In the year 1969, what is the difference between the Aid flow (current US$) in European Union and Aid flow (current US$) in United Kingdom?
Your answer should be compact. -1.64e+08. In the year 1969, what is the difference between the Aid flow (current US$) in European Union and Aid flow (current US$) in United States?
Provide a succinct answer. -2.01e+09. In the year 1969, what is the difference between the Aid flow (current US$) in European Union and Aid flow (current US$) in Iceland?
Make the answer very short. 5.03e+07. In the year 1969, what is the difference between the Aid flow (current US$) in United Kingdom and Aid flow (current US$) in United States?
Make the answer very short. -1.85e+09. In the year 1969, what is the difference between the Aid flow (current US$) of United Kingdom and Aid flow (current US$) of Iceland?
Make the answer very short. 2.14e+08. In the year 1969, what is the difference between the Aid flow (current US$) in United States and Aid flow (current US$) in Iceland?
Offer a very short reply. 2.07e+09. In the year 1970, what is the difference between the Aid flow (current US$) in European Union and Aid flow (current US$) in United Kingdom?
Provide a short and direct response. -1.57e+08. In the year 1970, what is the difference between the Aid flow (current US$) in European Union and Aid flow (current US$) in United States?
Offer a terse response. -1.88e+09. In the year 1970, what is the difference between the Aid flow (current US$) in European Union and Aid flow (current US$) in Iceland?
Your answer should be very brief. 8.76e+07. In the year 1970, what is the difference between the Aid flow (current US$) of United Kingdom and Aid flow (current US$) of United States?
Provide a short and direct response. -1.72e+09. In the year 1970, what is the difference between the Aid flow (current US$) in United Kingdom and Aid flow (current US$) in Iceland?
Make the answer very short. 2.44e+08. In the year 1970, what is the difference between the Aid flow (current US$) in United States and Aid flow (current US$) in Iceland?
Your answer should be compact. 1.96e+09. In the year 1971, what is the difference between the Aid flow (current US$) in European Union and Aid flow (current US$) in United Kingdom?
Your response must be concise. -1.93e+08. In the year 1971, what is the difference between the Aid flow (current US$) in European Union and Aid flow (current US$) in United States?
Make the answer very short. -1.92e+09. In the year 1971, what is the difference between the Aid flow (current US$) of European Union and Aid flow (current US$) of Iceland?
Your response must be concise. 1.13e+08. In the year 1971, what is the difference between the Aid flow (current US$) of United Kingdom and Aid flow (current US$) of United States?
Your answer should be compact. -1.72e+09. In the year 1971, what is the difference between the Aid flow (current US$) of United Kingdom and Aid flow (current US$) of Iceland?
Your answer should be very brief. 3.06e+08. In the year 1971, what is the difference between the Aid flow (current US$) of United States and Aid flow (current US$) of Iceland?
Offer a very short reply. 2.03e+09. In the year 1972, what is the difference between the Aid flow (current US$) of European Union and Aid flow (current US$) of United Kingdom?
Offer a terse response. -1.65e+08. In the year 1972, what is the difference between the Aid flow (current US$) of European Union and Aid flow (current US$) of United States?
Your response must be concise. -1.60e+09. In the year 1972, what is the difference between the Aid flow (current US$) in European Union and Aid flow (current US$) in Iceland?
Offer a terse response. 1.10e+08. In the year 1972, what is the difference between the Aid flow (current US$) in United Kingdom and Aid flow (current US$) in United States?
Ensure brevity in your answer.  -1.44e+09. In the year 1972, what is the difference between the Aid flow (current US$) of United Kingdom and Aid flow (current US$) of Iceland?
Keep it short and to the point. 2.75e+08. In the year 1972, what is the difference between the Aid flow (current US$) in United States and Aid flow (current US$) in Iceland?
Your answer should be compact. 1.71e+09. In the year 1973, what is the difference between the Aid flow (current US$) of European Union and Aid flow (current US$) of United Kingdom?
Give a very brief answer. -1.26e+08. In the year 1973, what is the difference between the Aid flow (current US$) of European Union and Aid flow (current US$) of United States?
Provide a succinct answer. -1.18e+09. In the year 1973, what is the difference between the Aid flow (current US$) in European Union and Aid flow (current US$) in Iceland?
Keep it short and to the point. 1.15e+08. In the year 1973, what is the difference between the Aid flow (current US$) in United Kingdom and Aid flow (current US$) in United States?
Your response must be concise. -1.05e+09. In the year 1973, what is the difference between the Aid flow (current US$) of United Kingdom and Aid flow (current US$) of Iceland?
Provide a short and direct response. 2.41e+08. In the year 1973, what is the difference between the Aid flow (current US$) in United States and Aid flow (current US$) in Iceland?
Keep it short and to the point. 1.29e+09. In the year 1974, what is the difference between the Aid flow (current US$) of European Union and Aid flow (current US$) of United Kingdom?
Make the answer very short. -1.14e+08. In the year 1974, what is the difference between the Aid flow (current US$) of European Union and Aid flow (current US$) of United States?
Your answer should be very brief. -1.09e+09. In the year 1974, what is the difference between the Aid flow (current US$) of European Union and Aid flow (current US$) of Iceland?
Offer a very short reply. 2.09e+08. In the year 1974, what is the difference between the Aid flow (current US$) in United Kingdom and Aid flow (current US$) in United States?
Make the answer very short. -9.75e+08. In the year 1974, what is the difference between the Aid flow (current US$) in United Kingdom and Aid flow (current US$) in Iceland?
Provide a succinct answer. 3.23e+08. In the year 1974, what is the difference between the Aid flow (current US$) in United States and Aid flow (current US$) in Iceland?
Your answer should be very brief. 1.30e+09. What is the ratio of the Aid flow (current US$) in European Union in 1968 to that in 1969?
Ensure brevity in your answer.  1.95. What is the ratio of the Aid flow (current US$) in United Kingdom in 1968 to that in 1969?
Provide a succinct answer. 1.12. What is the ratio of the Aid flow (current US$) of United States in 1968 to that in 1969?
Your answer should be very brief. 1.14. What is the ratio of the Aid flow (current US$) in Iceland in 1968 to that in 1969?
Offer a terse response. 0.79. What is the ratio of the Aid flow (current US$) of European Union in 1968 to that in 1970?
Ensure brevity in your answer.  1.13. What is the ratio of the Aid flow (current US$) in United Kingdom in 1968 to that in 1970?
Offer a terse response. 0.98. What is the ratio of the Aid flow (current US$) in United States in 1968 to that in 1970?
Provide a short and direct response. 1.19. What is the ratio of the Aid flow (current US$) in Iceland in 1968 to that in 1970?
Make the answer very short. 0.55. What is the ratio of the Aid flow (current US$) in European Union in 1968 to that in 1971?
Keep it short and to the point. 0.87. What is the ratio of the Aid flow (current US$) in United Kingdom in 1968 to that in 1971?
Provide a short and direct response. 0.78. What is the ratio of the Aid flow (current US$) of United States in 1968 to that in 1971?
Offer a terse response. 1.15. What is the ratio of the Aid flow (current US$) of Iceland in 1968 to that in 1971?
Give a very brief answer. 0.41. What is the ratio of the Aid flow (current US$) in European Union in 1968 to that in 1972?
Ensure brevity in your answer.  0.88. What is the ratio of the Aid flow (current US$) of United States in 1968 to that in 1972?
Your answer should be very brief. 1.36. What is the ratio of the Aid flow (current US$) in Iceland in 1968 to that in 1972?
Offer a very short reply. 0.28. What is the ratio of the Aid flow (current US$) of European Union in 1968 to that in 1973?
Your response must be concise. 0.82. What is the ratio of the Aid flow (current US$) of United Kingdom in 1968 to that in 1973?
Your response must be concise. 0.96. What is the ratio of the Aid flow (current US$) of United States in 1968 to that in 1973?
Give a very brief answer. 1.8. What is the ratio of the Aid flow (current US$) in Iceland in 1968 to that in 1973?
Ensure brevity in your answer.  0.21. What is the ratio of the Aid flow (current US$) of European Union in 1968 to that in 1974?
Give a very brief answer. 0.48. What is the ratio of the Aid flow (current US$) in United Kingdom in 1968 to that in 1974?
Your answer should be compact. 0.73. What is the ratio of the Aid flow (current US$) in United States in 1968 to that in 1974?
Give a very brief answer. 1.8. What is the ratio of the Aid flow (current US$) of Iceland in 1968 to that in 1974?
Provide a succinct answer. 0.3. What is the ratio of the Aid flow (current US$) in European Union in 1969 to that in 1970?
Provide a short and direct response. 0.58. What is the ratio of the Aid flow (current US$) in United Kingdom in 1969 to that in 1970?
Provide a succinct answer. 0.87. What is the ratio of the Aid flow (current US$) of United States in 1969 to that in 1970?
Your answer should be very brief. 1.05. What is the ratio of the Aid flow (current US$) in Iceland in 1969 to that in 1970?
Provide a succinct answer. 0.7. What is the ratio of the Aid flow (current US$) of European Union in 1969 to that in 1971?
Your answer should be compact. 0.45. What is the ratio of the Aid flow (current US$) of United Kingdom in 1969 to that in 1971?
Provide a short and direct response. 0.7. What is the ratio of the Aid flow (current US$) of United States in 1969 to that in 1971?
Give a very brief answer. 1.02. What is the ratio of the Aid flow (current US$) in Iceland in 1969 to that in 1971?
Make the answer very short. 0.52. What is the ratio of the Aid flow (current US$) in European Union in 1969 to that in 1972?
Your answer should be compact. 0.45. What is the ratio of the Aid flow (current US$) of United Kingdom in 1969 to that in 1972?
Make the answer very short. 0.77. What is the ratio of the Aid flow (current US$) of United States in 1969 to that in 1972?
Your answer should be very brief. 1.2. What is the ratio of the Aid flow (current US$) in Iceland in 1969 to that in 1972?
Ensure brevity in your answer.  0.35. What is the ratio of the Aid flow (current US$) in European Union in 1969 to that in 1973?
Ensure brevity in your answer.  0.42. What is the ratio of the Aid flow (current US$) of United Kingdom in 1969 to that in 1973?
Provide a short and direct response. 0.86. What is the ratio of the Aid flow (current US$) of United States in 1969 to that in 1973?
Offer a very short reply. 1.58. What is the ratio of the Aid flow (current US$) of Iceland in 1969 to that in 1973?
Offer a very short reply. 0.27. What is the ratio of the Aid flow (current US$) in European Union in 1969 to that in 1974?
Make the answer very short. 0.25. What is the ratio of the Aid flow (current US$) in United Kingdom in 1969 to that in 1974?
Keep it short and to the point. 0.66. What is the ratio of the Aid flow (current US$) in United States in 1969 to that in 1974?
Provide a succinct answer. 1.58. What is the ratio of the Aid flow (current US$) in Iceland in 1969 to that in 1974?
Offer a terse response. 0.39. What is the ratio of the Aid flow (current US$) of European Union in 1970 to that in 1971?
Ensure brevity in your answer.  0.77. What is the ratio of the Aid flow (current US$) in United Kingdom in 1970 to that in 1971?
Provide a succinct answer. 0.8. What is the ratio of the Aid flow (current US$) of United States in 1970 to that in 1971?
Your answer should be very brief. 0.97. What is the ratio of the Aid flow (current US$) of Iceland in 1970 to that in 1971?
Make the answer very short. 0.74. What is the ratio of the Aid flow (current US$) of European Union in 1970 to that in 1972?
Provide a short and direct response. 0.78. What is the ratio of the Aid flow (current US$) in United Kingdom in 1970 to that in 1972?
Give a very brief answer. 0.88. What is the ratio of the Aid flow (current US$) of United States in 1970 to that in 1972?
Offer a very short reply. 1.14. What is the ratio of the Aid flow (current US$) of Iceland in 1970 to that in 1972?
Make the answer very short. 0.51. What is the ratio of the Aid flow (current US$) of European Union in 1970 to that in 1973?
Your answer should be compact. 0.73. What is the ratio of the Aid flow (current US$) in United Kingdom in 1970 to that in 1973?
Provide a short and direct response. 0.98. What is the ratio of the Aid flow (current US$) of United States in 1970 to that in 1973?
Your answer should be compact. 1.51. What is the ratio of the Aid flow (current US$) of Iceland in 1970 to that in 1973?
Provide a short and direct response. 0.39. What is the ratio of the Aid flow (current US$) of European Union in 1970 to that in 1974?
Your answer should be very brief. 0.42. What is the ratio of the Aid flow (current US$) in United Kingdom in 1970 to that in 1974?
Ensure brevity in your answer.  0.75. What is the ratio of the Aid flow (current US$) in United States in 1970 to that in 1974?
Your response must be concise. 1.51. What is the ratio of the Aid flow (current US$) in Iceland in 1970 to that in 1974?
Offer a very short reply. 0.56. What is the ratio of the Aid flow (current US$) in European Union in 1971 to that in 1972?
Your answer should be very brief. 1.01. What is the ratio of the Aid flow (current US$) in United Kingdom in 1971 to that in 1972?
Provide a short and direct response. 1.1. What is the ratio of the Aid flow (current US$) of United States in 1971 to that in 1972?
Your answer should be very brief. 1.18. What is the ratio of the Aid flow (current US$) of Iceland in 1971 to that in 1972?
Offer a terse response. 0.69. What is the ratio of the Aid flow (current US$) of European Union in 1971 to that in 1973?
Your answer should be compact. 0.94. What is the ratio of the Aid flow (current US$) of United Kingdom in 1971 to that in 1973?
Make the answer very short. 1.24. What is the ratio of the Aid flow (current US$) in United States in 1971 to that in 1973?
Ensure brevity in your answer.  1.56. What is the ratio of the Aid flow (current US$) of Iceland in 1971 to that in 1973?
Make the answer very short. 0.52. What is the ratio of the Aid flow (current US$) in European Union in 1971 to that in 1974?
Provide a short and direct response. 0.55. What is the ratio of the Aid flow (current US$) of United Kingdom in 1971 to that in 1974?
Your answer should be compact. 0.94. What is the ratio of the Aid flow (current US$) of United States in 1971 to that in 1974?
Provide a short and direct response. 1.56. What is the ratio of the Aid flow (current US$) in Iceland in 1971 to that in 1974?
Your answer should be very brief. 0.75. What is the ratio of the Aid flow (current US$) in European Union in 1972 to that in 1973?
Your response must be concise. 0.93. What is the ratio of the Aid flow (current US$) of United Kingdom in 1972 to that in 1973?
Make the answer very short. 1.12. What is the ratio of the Aid flow (current US$) in United States in 1972 to that in 1973?
Give a very brief answer. 1.32. What is the ratio of the Aid flow (current US$) in Iceland in 1972 to that in 1973?
Offer a terse response. 0.76. What is the ratio of the Aid flow (current US$) of European Union in 1972 to that in 1974?
Provide a succinct answer. 0.54. What is the ratio of the Aid flow (current US$) in United Kingdom in 1972 to that in 1974?
Keep it short and to the point. 0.86. What is the ratio of the Aid flow (current US$) of United States in 1972 to that in 1974?
Provide a succinct answer. 1.32. What is the ratio of the Aid flow (current US$) in Iceland in 1972 to that in 1974?
Your answer should be compact. 1.09. What is the ratio of the Aid flow (current US$) in European Union in 1973 to that in 1974?
Provide a short and direct response. 0.58. What is the ratio of the Aid flow (current US$) in United Kingdom in 1973 to that in 1974?
Offer a terse response. 0.76. What is the ratio of the Aid flow (current US$) in Iceland in 1973 to that in 1974?
Make the answer very short. 1.44. What is the difference between the highest and the second highest Aid flow (current US$) in European Union?
Your answer should be compact. 9.03e+07. What is the difference between the highest and the second highest Aid flow (current US$) of United Kingdom?
Ensure brevity in your answer.  1.92e+07. What is the difference between the highest and the second highest Aid flow (current US$) in United States?
Offer a terse response. 2.80e+08. What is the difference between the highest and the second highest Aid flow (current US$) in Iceland?
Ensure brevity in your answer.  2.57e+06. What is the difference between the highest and the lowest Aid flow (current US$) in European Union?
Give a very brief answer. 1.63e+08. What is the difference between the highest and the lowest Aid flow (current US$) of United Kingdom?
Ensure brevity in your answer.  1.14e+08. What is the difference between the highest and the lowest Aid flow (current US$) of United States?
Your answer should be compact. 1.04e+09. What is the difference between the highest and the lowest Aid flow (current US$) in Iceland?
Give a very brief answer. 8.38e+06. 